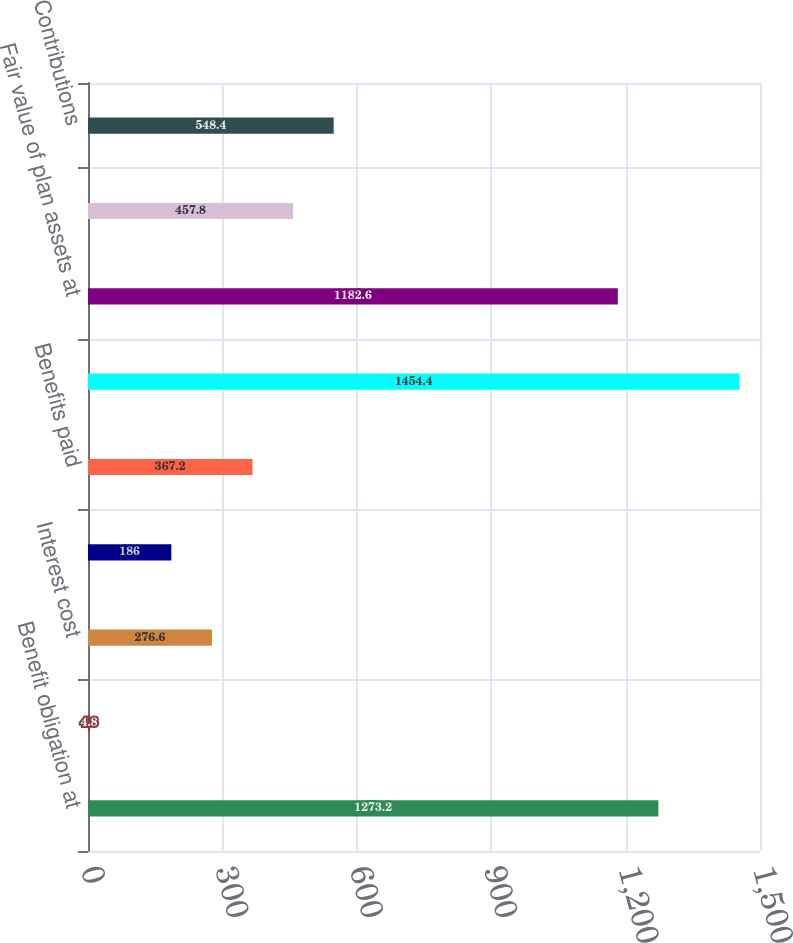Convert chart to OTSL. <chart><loc_0><loc_0><loc_500><loc_500><bar_chart><fcel>Benefit obligation at<fcel>Service cost<fcel>Interest cost<fcel>Actuarial (gain) loss<fcel>Benefits paid<fcel>Benefit obligation at end of<fcel>Fair value of plan assets at<fcel>Actual return on plan assets<fcel>Contributions<nl><fcel>1273.2<fcel>4.8<fcel>276.6<fcel>186<fcel>367.2<fcel>1454.4<fcel>1182.6<fcel>457.8<fcel>548.4<nl></chart> 